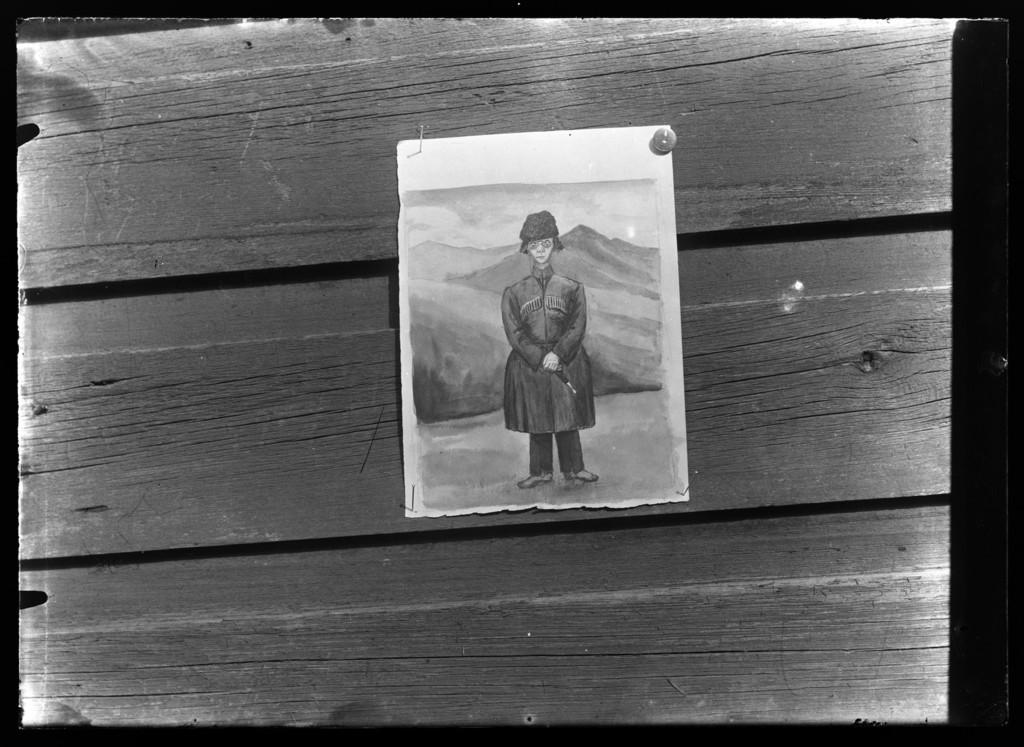What is depicted on the paper in the image? The paper has a painting of a person on it. How is the paper displayed in the image? The paper is attached to a wooden wall. What type of animal can be seen at the zoo in the image? There is no zoo or animal present in the image; it features a paper with a painting of a person on it. 